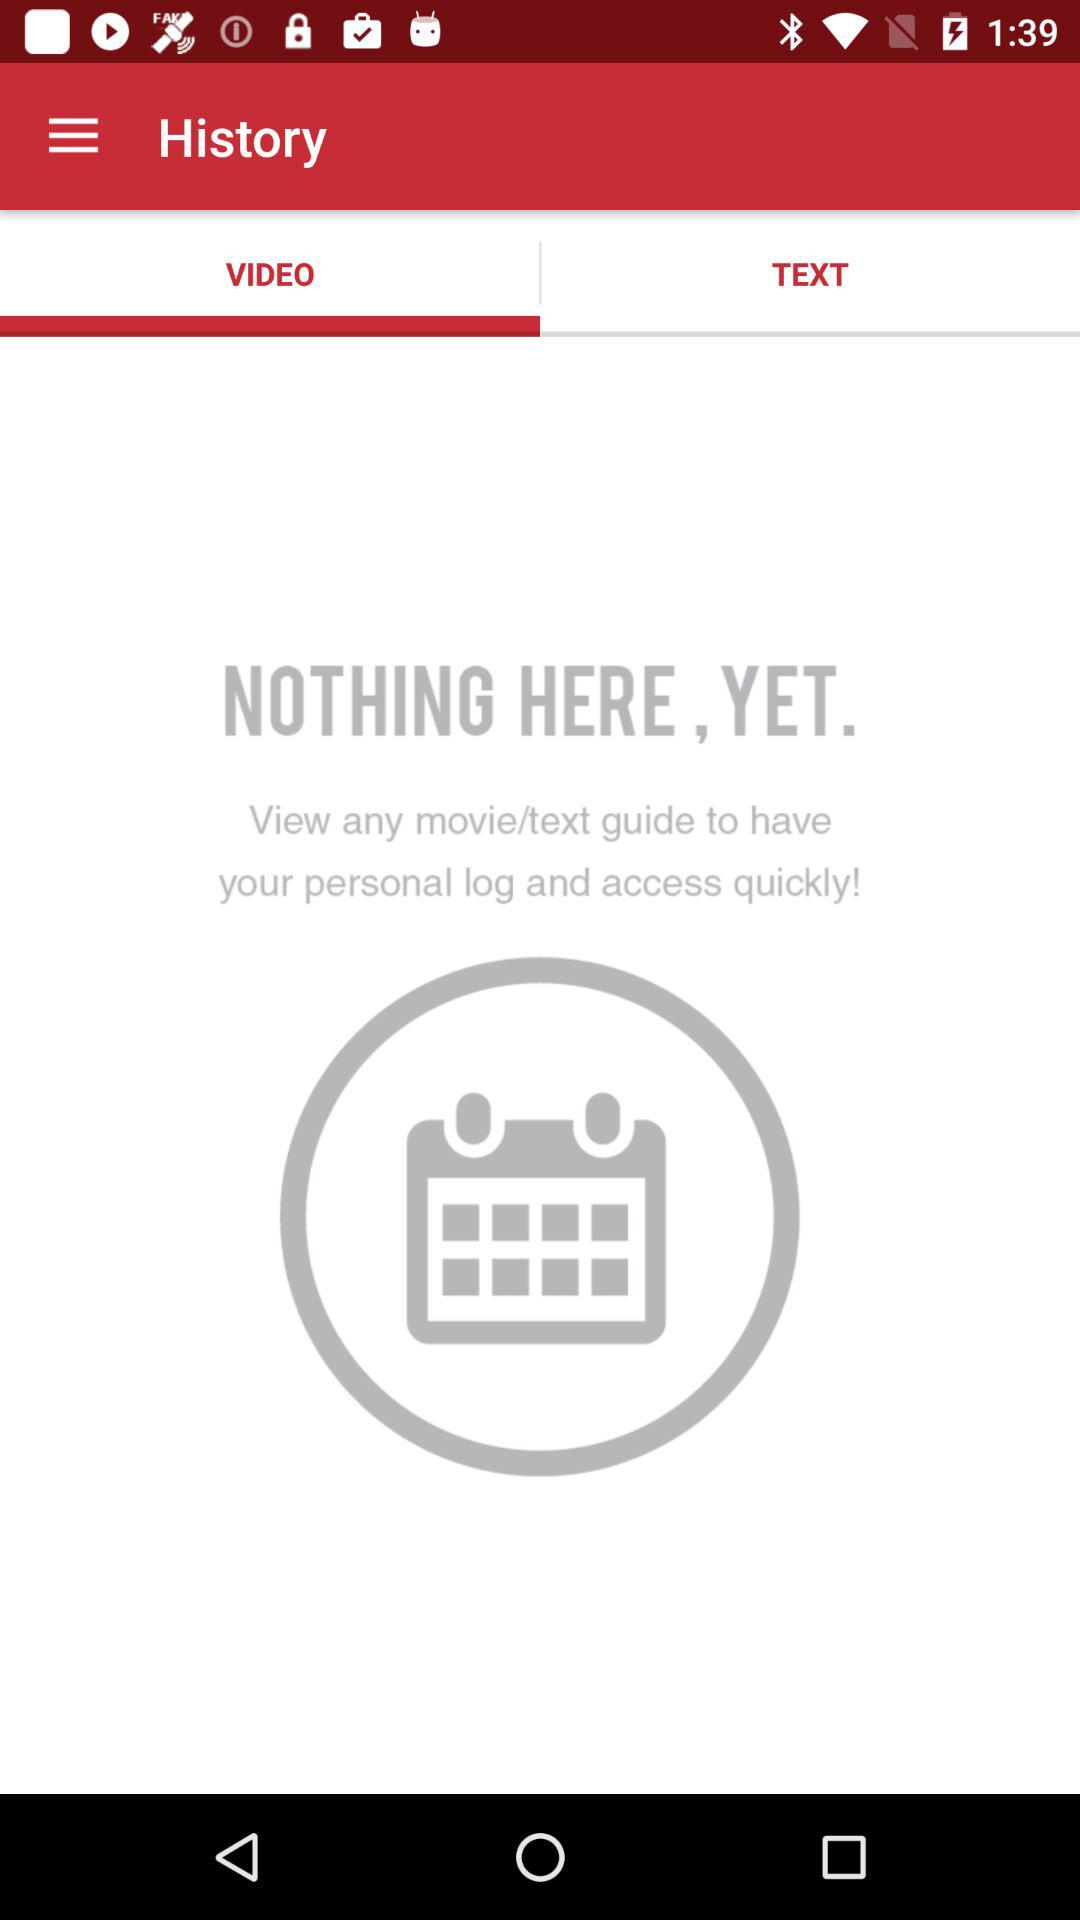Which option is selected? The selected option is "VIDEO". 